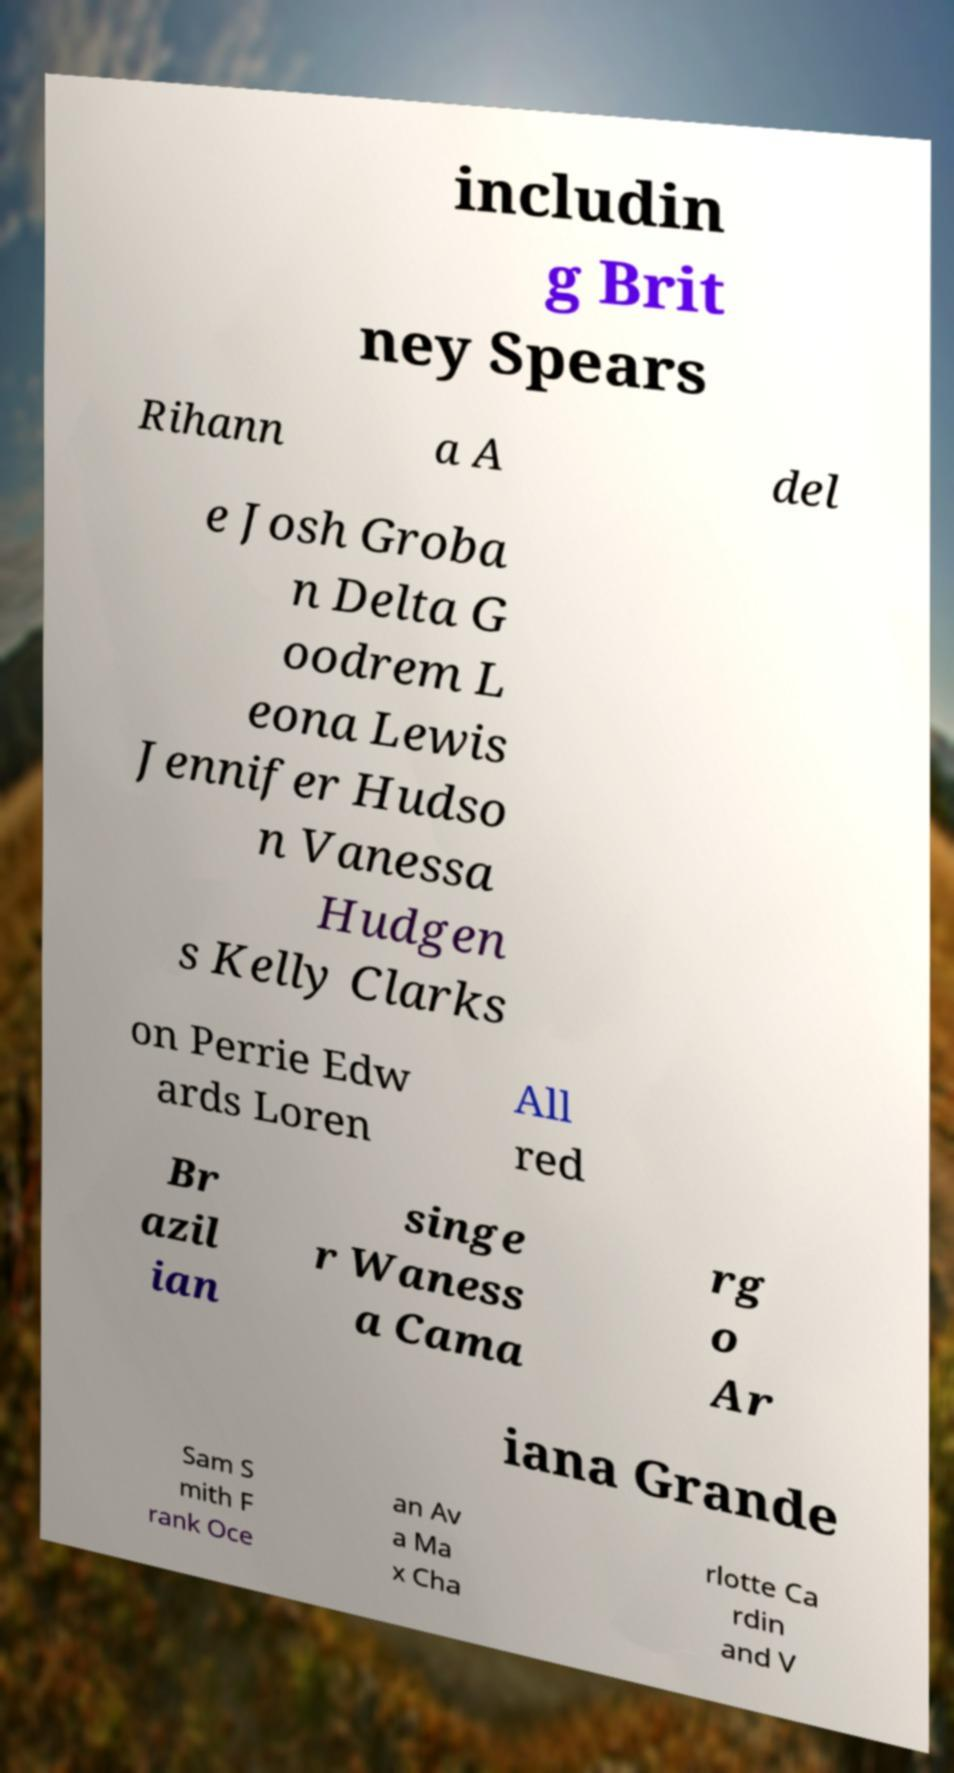Please identify and transcribe the text found in this image. includin g Brit ney Spears Rihann a A del e Josh Groba n Delta G oodrem L eona Lewis Jennifer Hudso n Vanessa Hudgen s Kelly Clarks on Perrie Edw ards Loren All red Br azil ian singe r Waness a Cama rg o Ar iana Grande Sam S mith F rank Oce an Av a Ma x Cha rlotte Ca rdin and V 